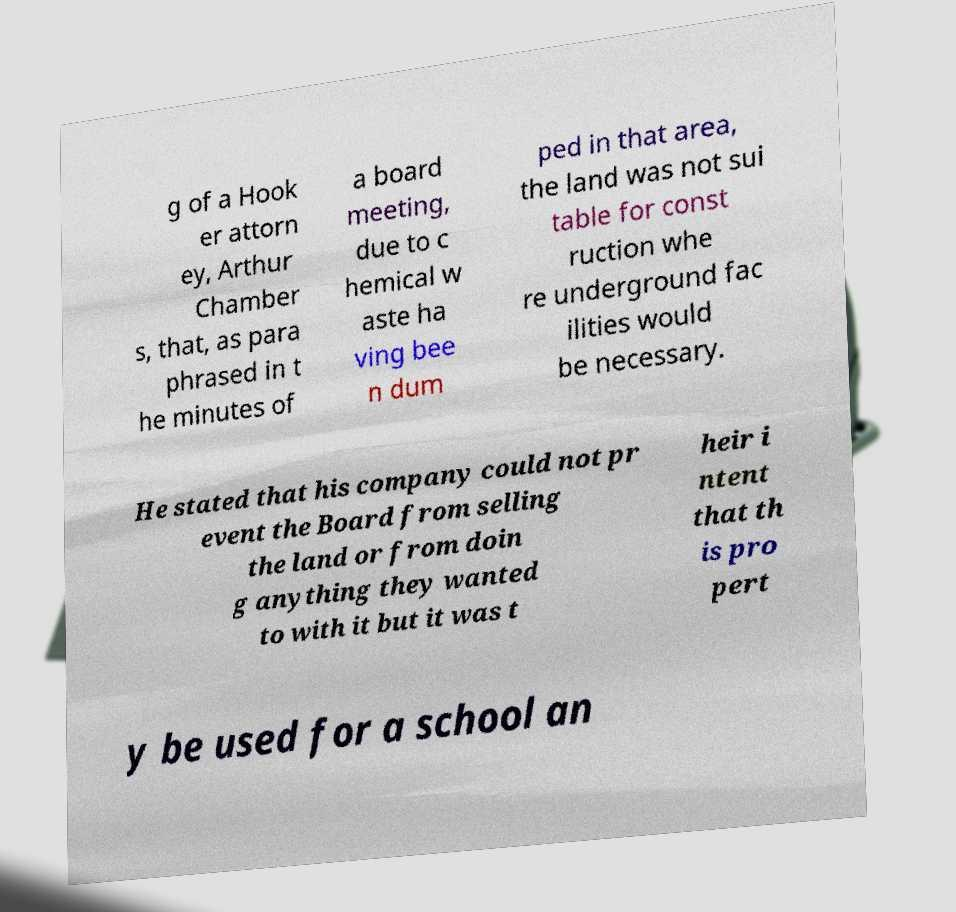I need the written content from this picture converted into text. Can you do that? g of a Hook er attorn ey, Arthur Chamber s, that, as para phrased in t he minutes of a board meeting, due to c hemical w aste ha ving bee n dum ped in that area, the land was not sui table for const ruction whe re underground fac ilities would be necessary. He stated that his company could not pr event the Board from selling the land or from doin g anything they wanted to with it but it was t heir i ntent that th is pro pert y be used for a school an 